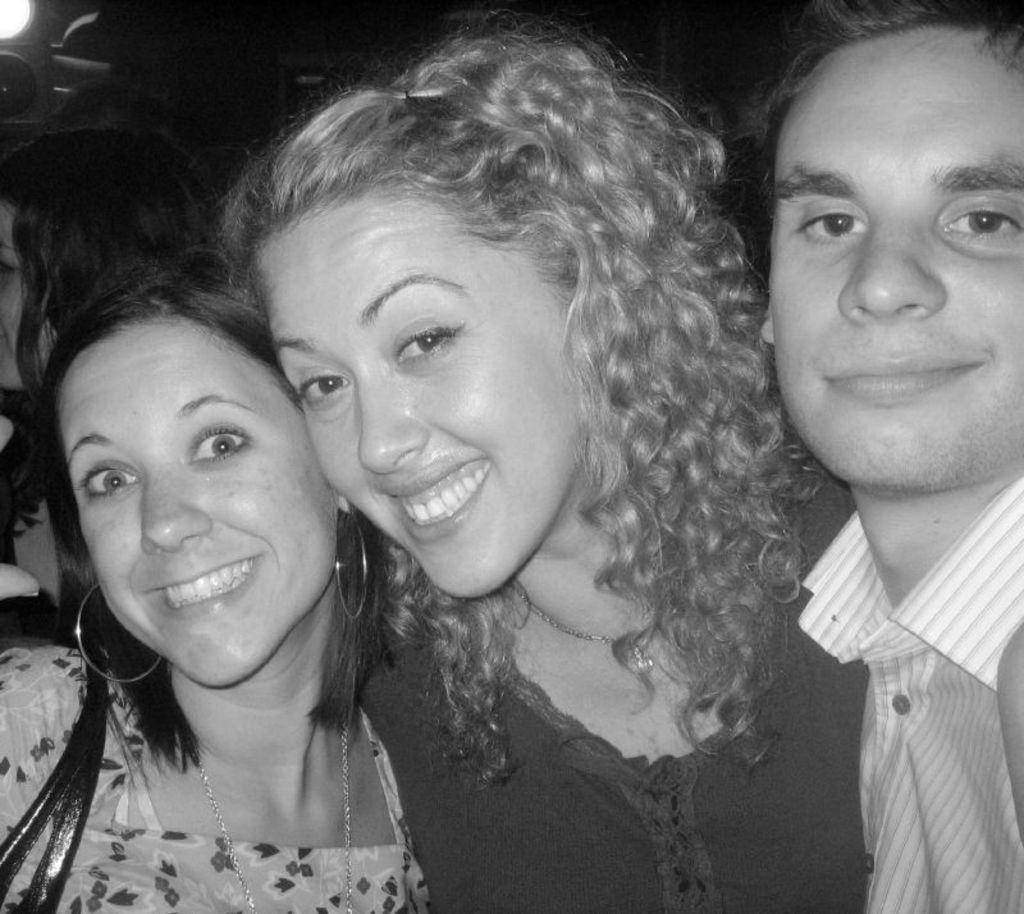How many people are in the image? There are persons in the image, but the exact number is not specified. Where are the persons located in the image? The persons are standing in the middle of the image. What expression do the persons have in the image? The persons are smiling. What type of stamp can be seen on the person's forehead in the image? There is no stamp visible on anyone's forehead in the image. What kind of rice is being served in the image? There is no rice present in the image. 